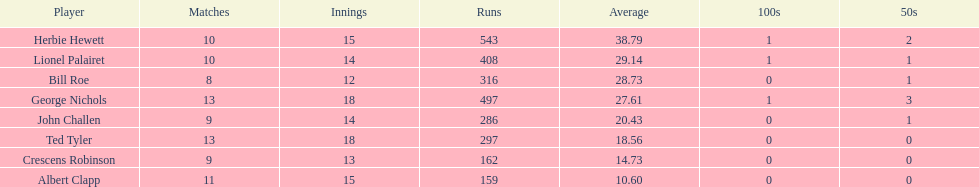Name a player whose average was above 25. Herbie Hewett. 